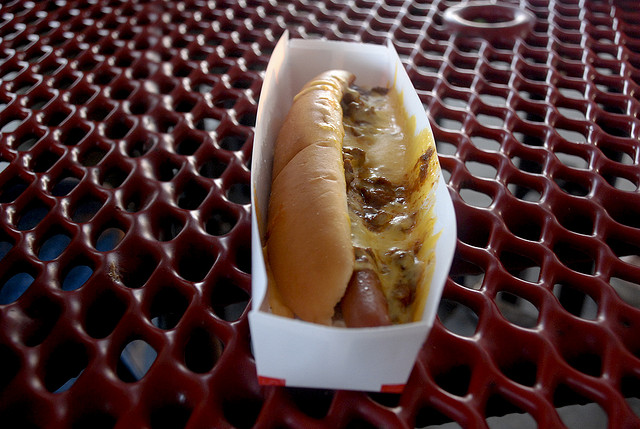Describe the setting where the hot dog is placed. The hot dog is resting in a paper tray, which is placed on a red metal table with a diamond-shaped pattern that could be typically found in outdoor picnic areas or food courts. 